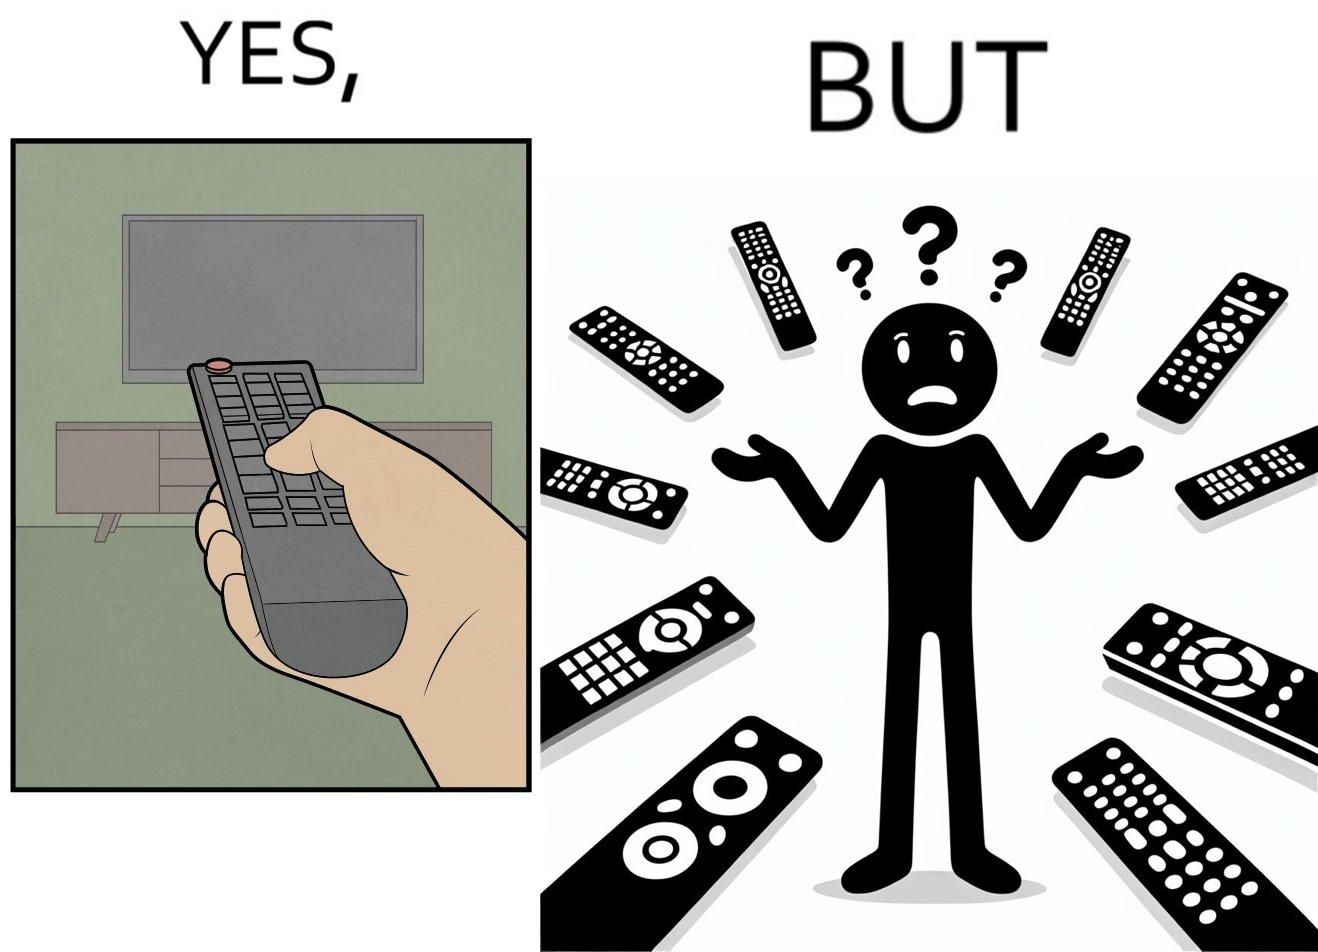Explain the humor or irony in this image. The images are funny since they show how even though TV remotes are supposed to make operating TVs easier, having multiple similar looking remotes  for everything only makes it more difficult for the user to use the right one 